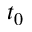<formula> <loc_0><loc_0><loc_500><loc_500>t _ { 0 }</formula> 